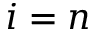Convert formula to latex. <formula><loc_0><loc_0><loc_500><loc_500>i = n</formula> 